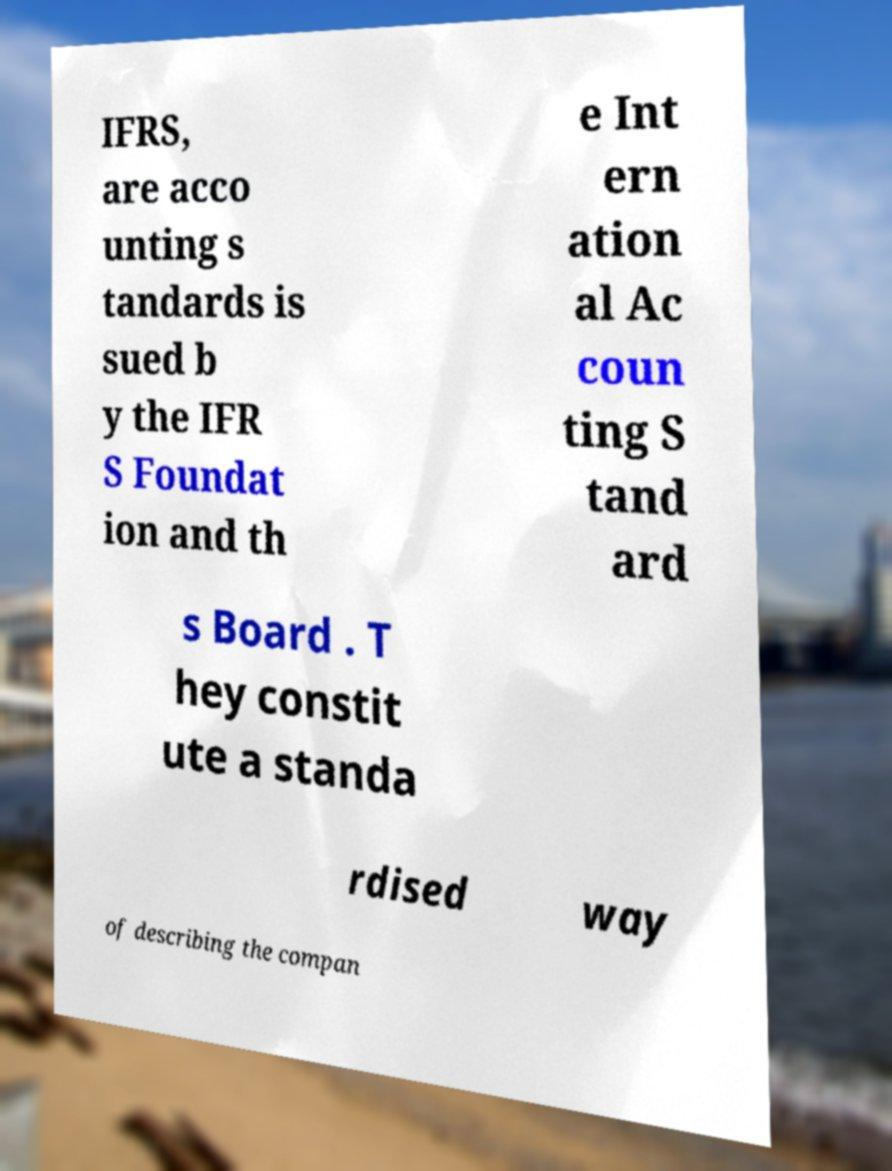Can you read and provide the text displayed in the image?This photo seems to have some interesting text. Can you extract and type it out for me? IFRS, are acco unting s tandards is sued b y the IFR S Foundat ion and th e Int ern ation al Ac coun ting S tand ard s Board . T hey constit ute a standa rdised way of describing the compan 